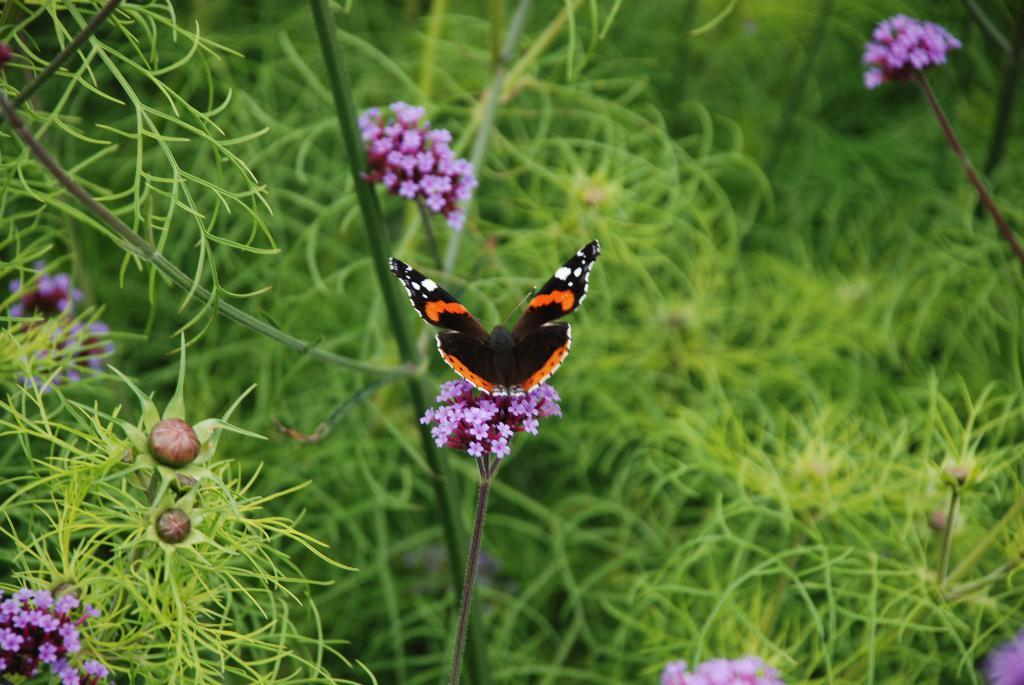What type of plants can be seen in the image? There are plants with flowers in the image. What other living organism is present in the image? There is a butterfly in the image. Can you describe the color of the butterfly? The butterfly is black and orange in color. Are there any additional details about the butterfly's appearance? Yes, the butterfly has white dots. What type of paint is used to create the earth's texture in the image? There is no mention of the earth or any paint in the image; it features plants with flowers and a butterfly. 